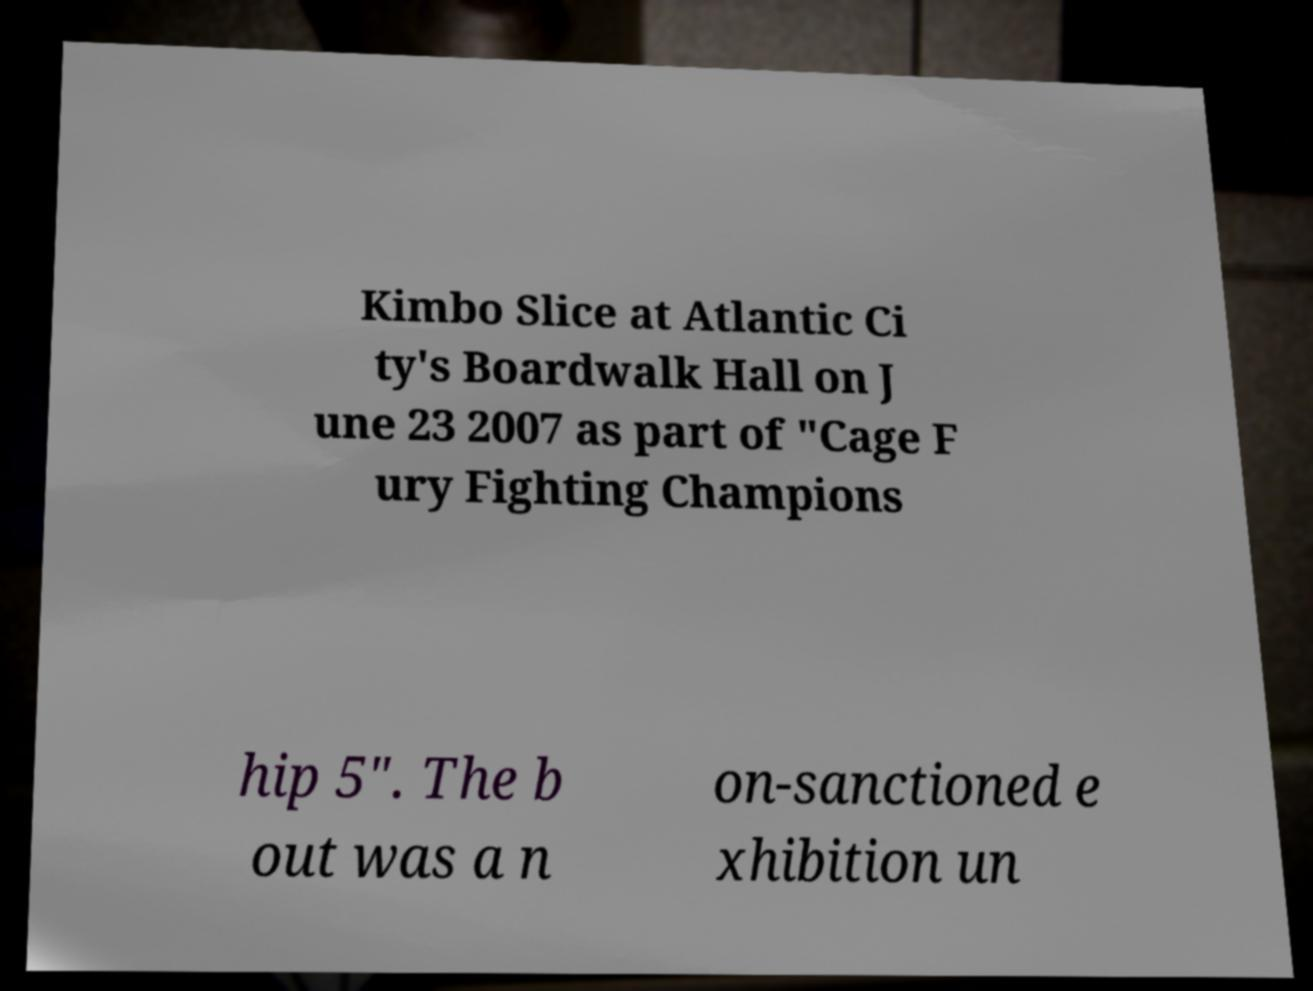Please identify and transcribe the text found in this image. Kimbo Slice at Atlantic Ci ty's Boardwalk Hall on J une 23 2007 as part of "Cage F ury Fighting Champions hip 5". The b out was a n on-sanctioned e xhibition un 